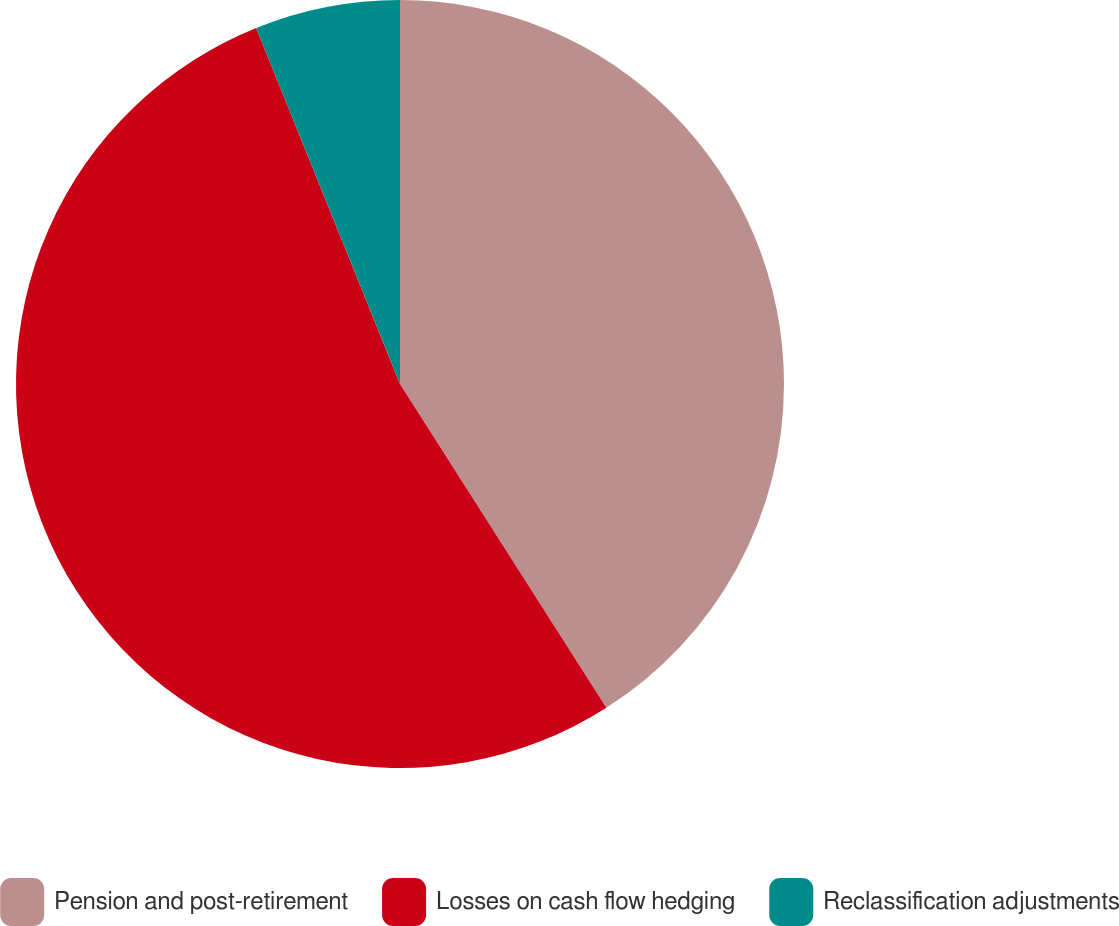Convert chart to OTSL. <chart><loc_0><loc_0><loc_500><loc_500><pie_chart><fcel>Pension and post-retirement<fcel>Losses on cash flow hedging<fcel>Reclassification adjustments<nl><fcel>40.97%<fcel>52.92%<fcel>6.11%<nl></chart> 